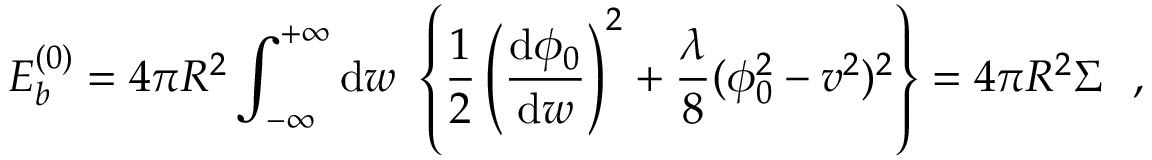<formula> <loc_0><loc_0><loc_500><loc_500>E _ { b } ^ { ( 0 ) } = 4 \pi R ^ { 2 } \int _ { - \infty } ^ { + \infty } d w \left \{ \frac { 1 } { 2 } \left ( \frac { d \phi _ { 0 } } { d w } \right ) ^ { 2 } + \frac { \lambda } { 8 } ( \phi _ { 0 } ^ { 2 } - v ^ { 2 } ) ^ { 2 } \right \} = 4 \pi R ^ { 2 } \Sigma ,</formula> 